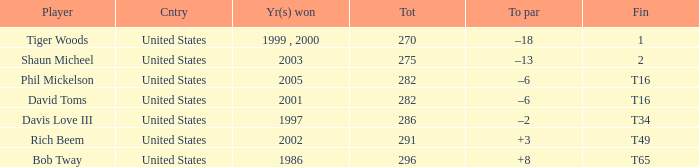In what place did Phil Mickelson finish with a total of 282? T16. 